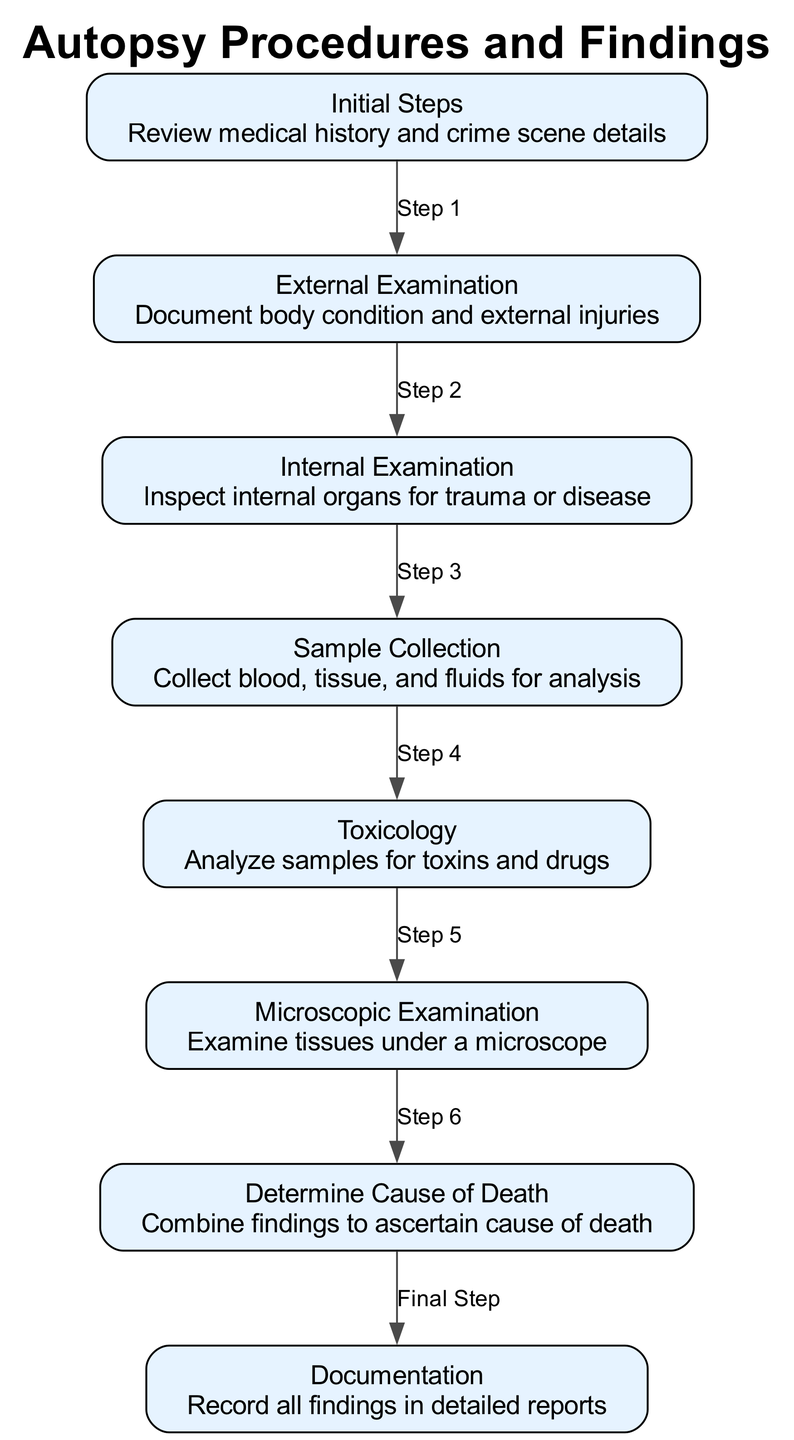What is the first step in the autopsy process? The first step listed is "Initial Steps," which involves reviewing medical history and crime scene details.
Answer: Initial Steps How many nodes are present in the diagram? The diagram lists 8 nodes, each representing a distinct part of the autopsy process.
Answer: 8 What step comes after the external examination? After the "External Examination," the next step is "Internal Examination," which inspects internal organs for trauma or disease.
Answer: Internal Examination What type of examination includes analyzing samples for toxins? The "Toxicology" step involves analyzing samples for toxins and drugs.
Answer: Toxicology Which step in the process culminates in recording all findings? The final step in the process is "Documentation," where all findings are recorded in detailed reports.
Answer: Documentation How do the findings from microscopic examination contribute to autopsy conclusions? The "Microscopic Examination" allows for a detailed examination of tissues under a microscope, which provides crucial information needed to ascertain the "Cause of Death." Thus, the findings from this step are integrated into determining how the death occurred.
Answer: Cause of Death What is the relationship between sample collection and toxicology? After "Sample Collection," which involves collecting blood, tissue, and fluids, the samples are then analyzed for toxins and drugs in the "Toxicology" step, as indicated by the directed edge in the diagram.
Answer: Step 4 List two types of examinations included in the autopsy procedures. The autopsy procedures include "External Examination" and "Internal Examination," both of which are essential for documenting injuries and inspecting organs.
Answer: External Examination, Internal Examination What is the process flow from initial steps to documentation? The process flow begins with "Initial Steps," followed by "External Examination," then "Internal Examination," followed by "Sample Collection," then "Toxicology," leading to "Microscopic Examination," which culminates in determining the "Cause of Death," and finally, "Documentation." This sequential flow illustrates the comprehensive nature of the autopsy process.
Answer: Initial Steps → External Examination → Internal Examination → Sample Collection → Toxicology → Microscopic Examination → Cause of Death → Documentation 